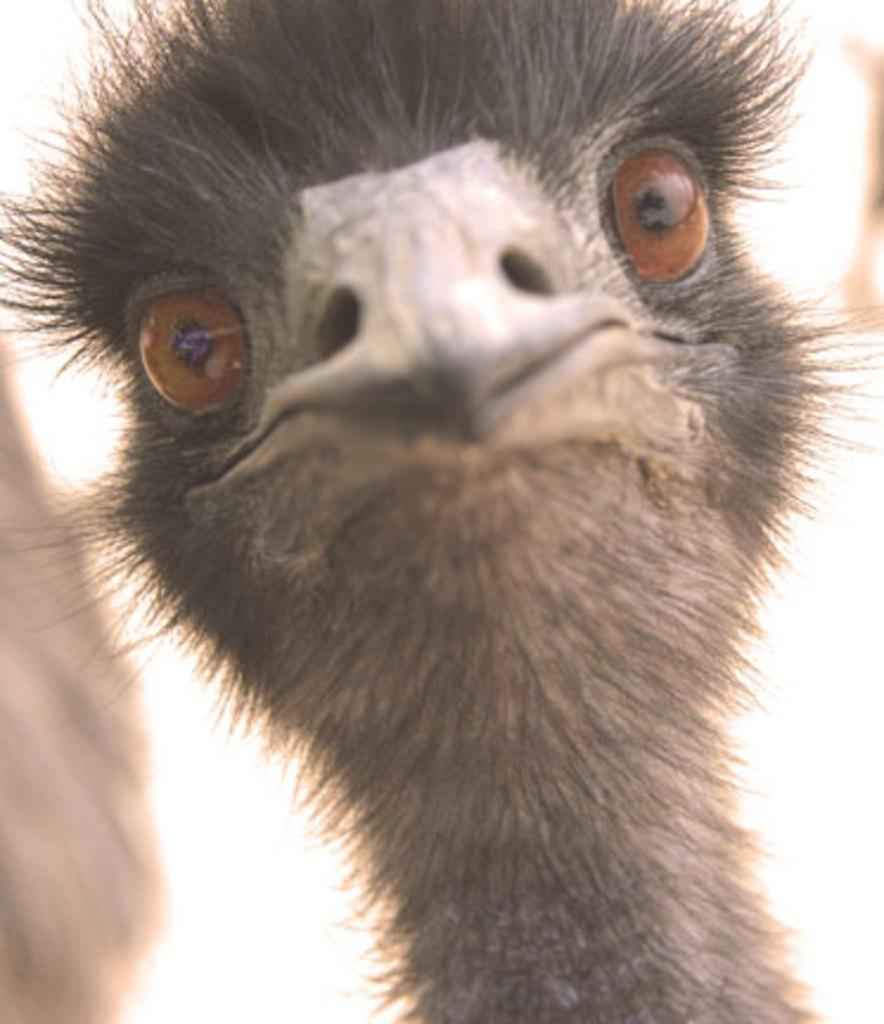What type of animal is present in the image? There is a bird in the image. Can you describe any specific features of the bird? The bird has a sharp beak and round eyes. How many pies are on the sofa in the image? There is no sofa or pies present in the image; it only features a bird. What type of star can be seen in the image? There is no star present in the image; it only features a bird. 